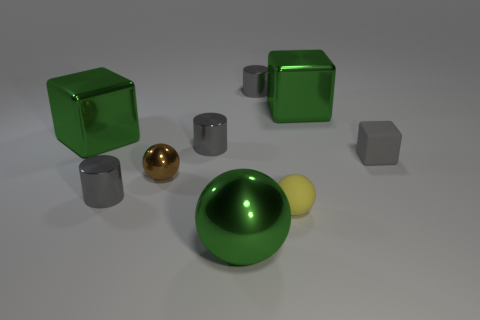How many gray cylinders must be subtracted to get 1 gray cylinders? 2 Add 1 yellow matte things. How many objects exist? 10 Subtract all tiny balls. How many balls are left? 1 Subtract all green spheres. How many spheres are left? 2 Subtract all blocks. How many objects are left? 6 Subtract 1 cubes. How many cubes are left? 2 Subtract all green spheres. Subtract all cyan blocks. How many spheres are left? 2 Subtract all blue balls. How many blue cylinders are left? 0 Subtract all tiny gray metal cylinders. Subtract all metal spheres. How many objects are left? 4 Add 7 gray shiny cylinders. How many gray shiny cylinders are left? 10 